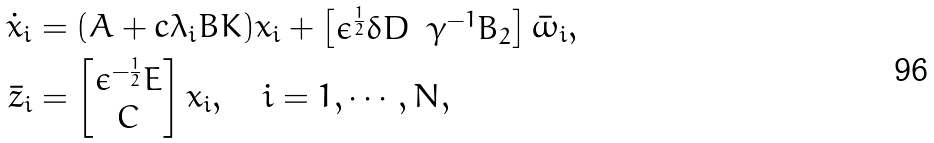<formula> <loc_0><loc_0><loc_500><loc_500>\dot { x } _ { i } & = ( A + c \lambda _ { i } B K ) x _ { i } + \begin{bmatrix} \epsilon ^ { \frac { 1 } { 2 } } \delta D & \gamma ^ { - 1 } B _ { 2 } \end{bmatrix} \bar { \omega } _ { i } , \\ \bar { z } _ { i } & = \begin{bmatrix} \epsilon ^ { - \frac { 1 } { 2 } } E \\ C \end{bmatrix} x _ { i } , \quad i = 1 , \cdots , N ,</formula> 